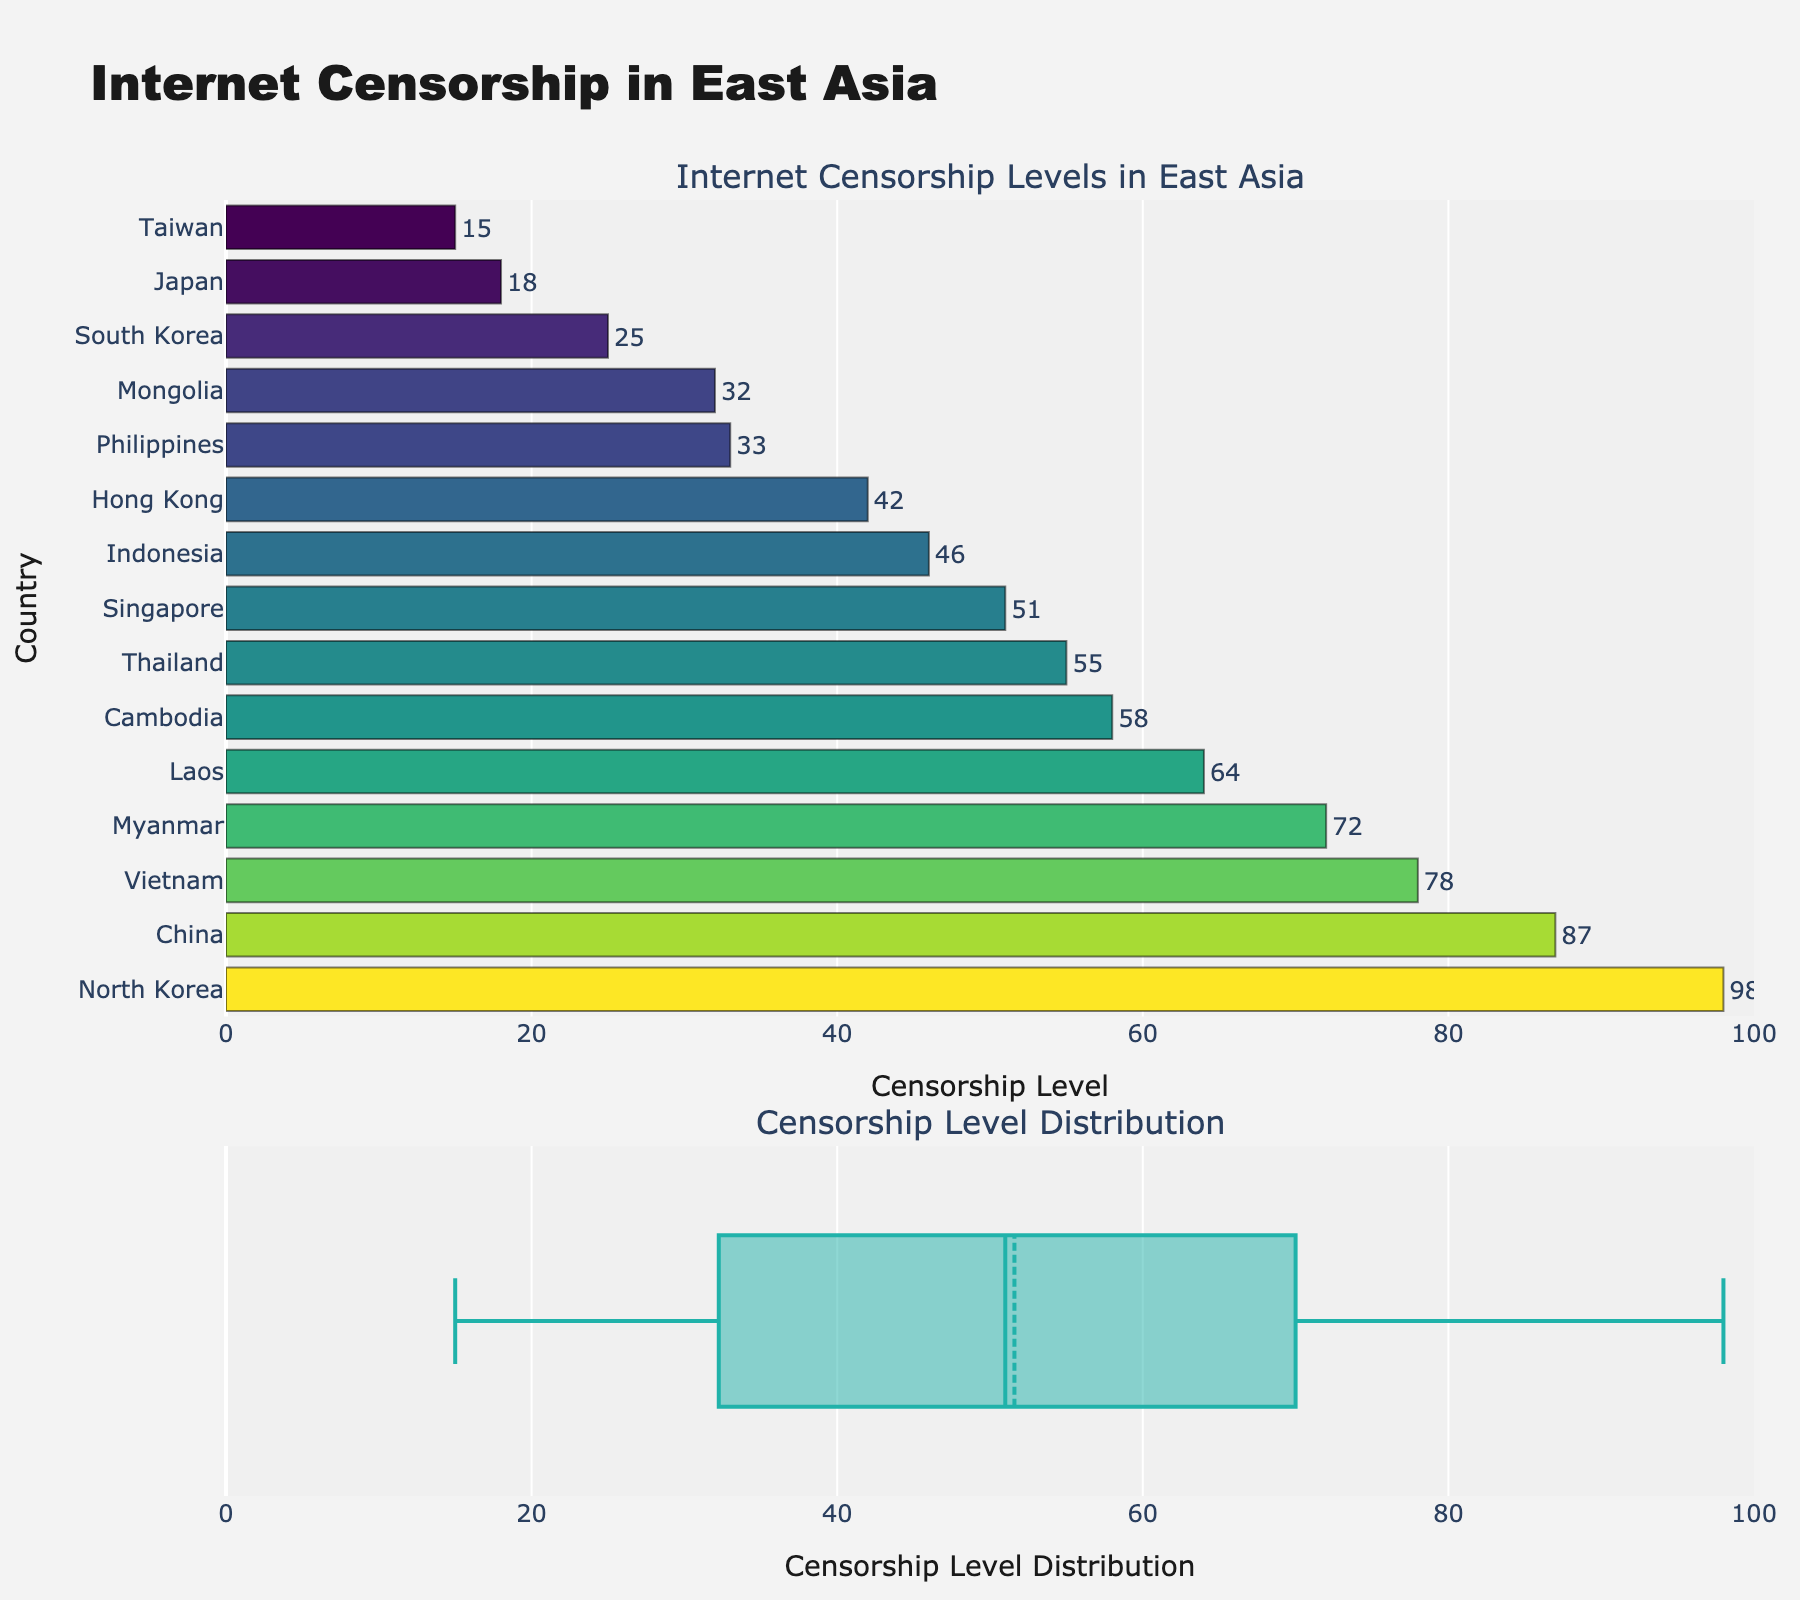How many countries are included in the plot? By counting the number of bars, each representing a country, or the number of boxplot data points, we can determine the total number of countries.
Answer: 15 Which country has the highest level of internet censorship? The country with the highest bar in the bar chart represents the highest level of internet censorship.
Answer: North Korea What is the censorship level in Taiwan? By finding "Taiwan" on the y-axis and reading its corresponding value from the x-axis of the bar chart.
Answer: 15 What is the median censorship level among these East Asian countries? The median level is indicated by the central line in the boxplot on the second subplot.
Answer: Approximately 46 Which country has a lower censorship level, Mongolia or Thailand? By comparing the height of the bars for Mongolia and Thailand in the bar chart.
Answer: Mongolia What is the average internet censorship level among these countries? To find the average, sum all the censorship levels and divide by the number of countries. ((87+98+78+64+72+25+18+15+42+32+55+58+51+33+46)/15).
Answer: Approximately 52.6 How many countries have a censorship level above 50? Count the number of bars that are above the 50 mark on the x-axis in the bar chart.
Answer: 8 What is the range of internet censorship levels in East Asia? The range is the difference between the highest and lowest censorship levels in the boxplot.
Answer: 98 - 15 = 83 Which country has a censorship level closest to the average level of the group? First, calculate the average level, then find the bar closest to this value. The calculation shows it's approximately 52.6. The country closest to this level is Singapore with 51.
Answer: Singapore 